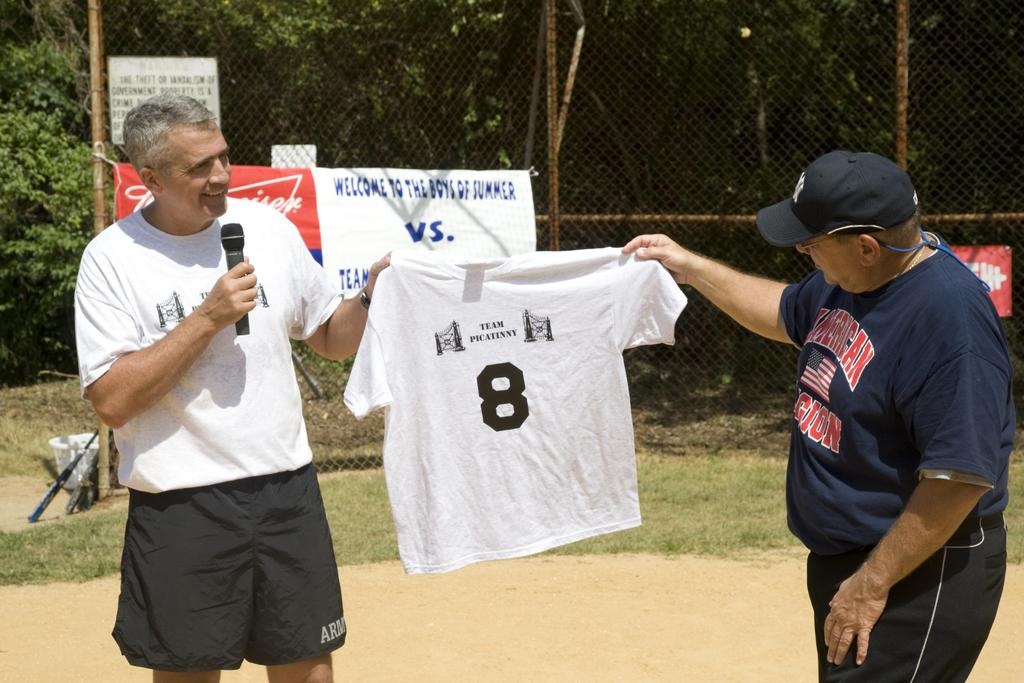<image>
Give a short and clear explanation of the subsequent image. An elderly man in an American Legion shirt holds up another shirt with another man. 